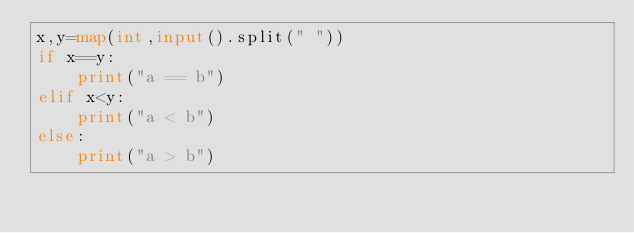<code> <loc_0><loc_0><loc_500><loc_500><_Python_>x,y=map(int,input().split(" "))
if x==y:
    print("a == b")
elif x<y:
    print("a < b")
else:
    print("a > b")</code> 